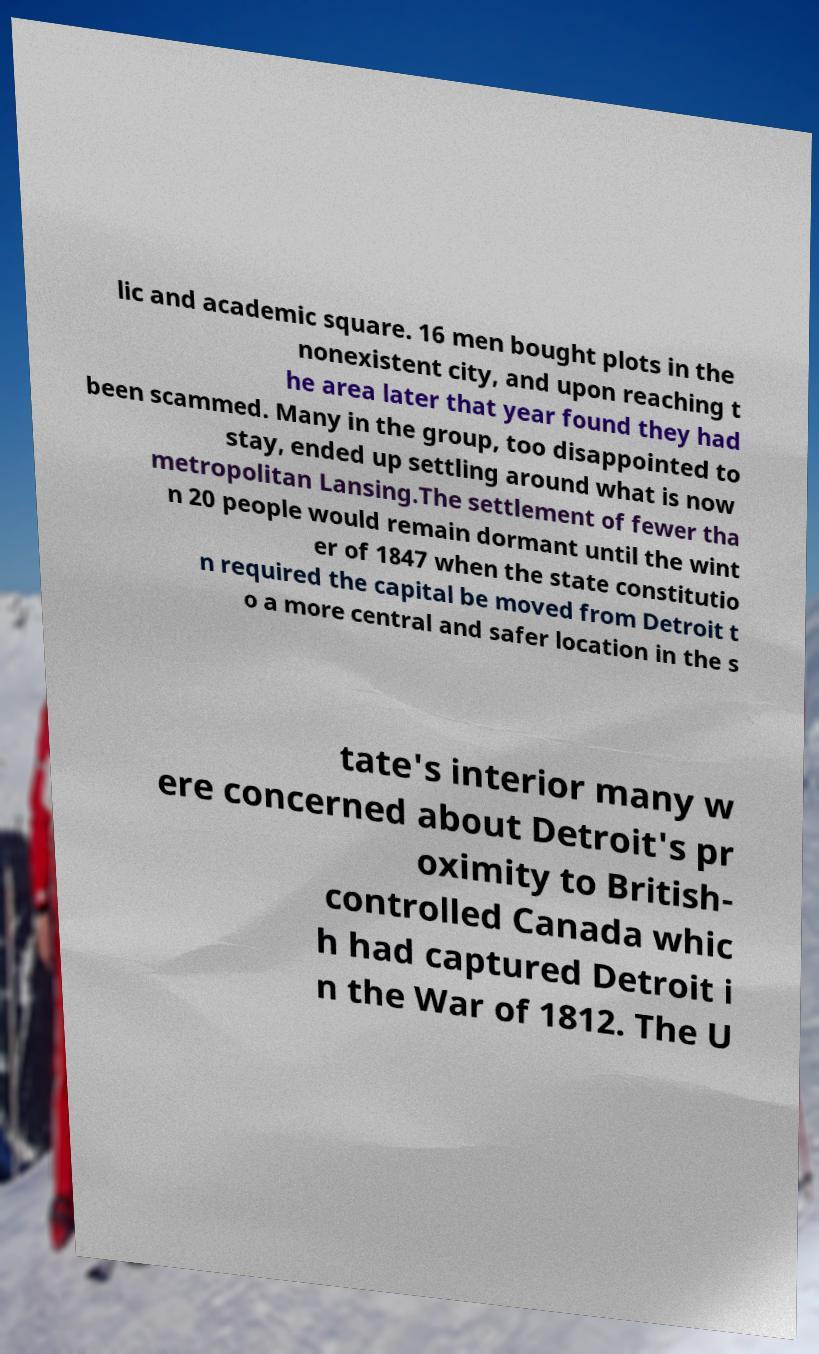I need the written content from this picture converted into text. Can you do that? lic and academic square. 16 men bought plots in the nonexistent city, and upon reaching t he area later that year found they had been scammed. Many in the group, too disappointed to stay, ended up settling around what is now metropolitan Lansing.The settlement of fewer tha n 20 people would remain dormant until the wint er of 1847 when the state constitutio n required the capital be moved from Detroit t o a more central and safer location in the s tate's interior many w ere concerned about Detroit's pr oximity to British- controlled Canada whic h had captured Detroit i n the War of 1812. The U 